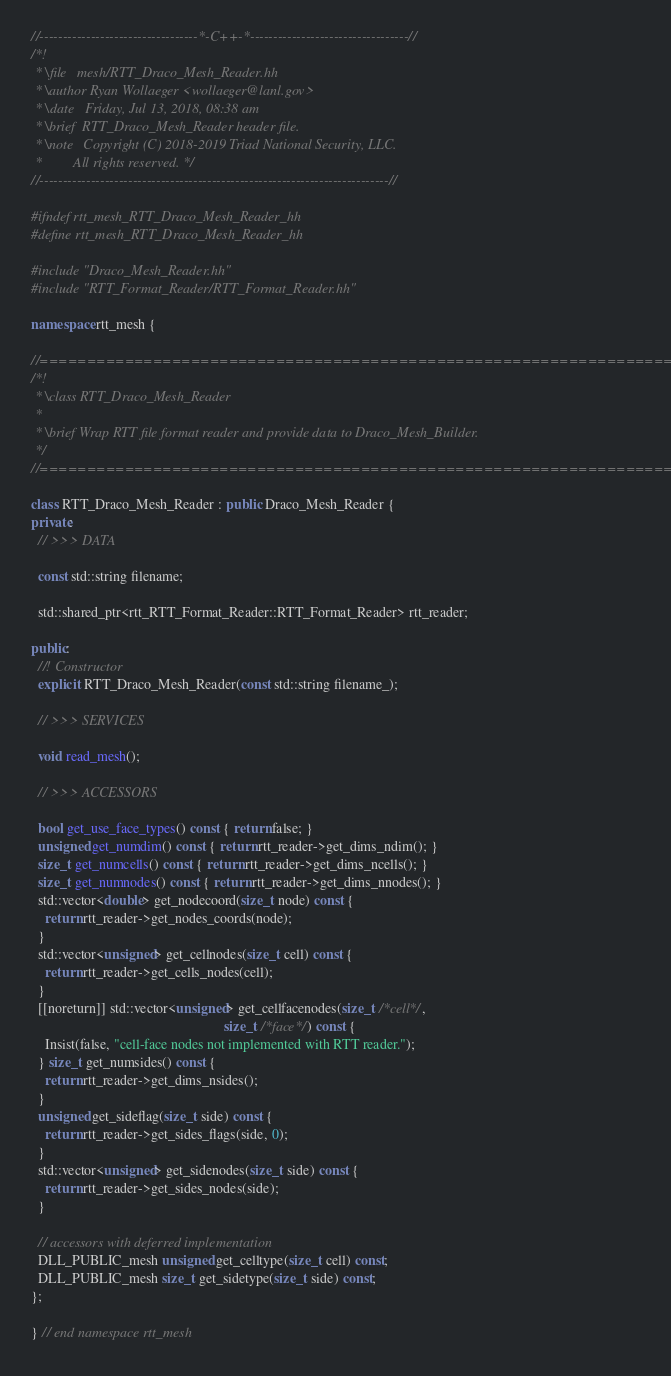Convert code to text. <code><loc_0><loc_0><loc_500><loc_500><_C++_>//----------------------------------*-C++-*----------------------------------//
/*!
 * \file   mesh/RTT_Draco_Mesh_Reader.hh
 * \author Ryan Wollaeger <wollaeger@lanl.gov>
 * \date   Friday, Jul 13, 2018, 08:38 am
 * \brief  RTT_Draco_Mesh_Reader header file.
 * \note   Copyright (C) 2018-2019 Triad National Security, LLC.
 *         All rights reserved. */
//---------------------------------------------------------------------------//

#ifndef rtt_mesh_RTT_Draco_Mesh_Reader_hh
#define rtt_mesh_RTT_Draco_Mesh_Reader_hh

#include "Draco_Mesh_Reader.hh"
#include "RTT_Format_Reader/RTT_Format_Reader.hh"

namespace rtt_mesh {

//===========================================================================//
/*!
 * \class RTT_Draco_Mesh_Reader
 *
 * \brief Wrap RTT file format reader and provide data to Draco_Mesh_Builder.
 */
//===========================================================================//

class RTT_Draco_Mesh_Reader : public Draco_Mesh_Reader {
private:
  // >>> DATA

  const std::string filename;

  std::shared_ptr<rtt_RTT_Format_Reader::RTT_Format_Reader> rtt_reader;

public:
  //! Constructor
  explicit RTT_Draco_Mesh_Reader(const std::string filename_);

  // >>> SERVICES

  void read_mesh();

  // >>> ACCESSORS

  bool get_use_face_types() const { return false; }
  unsigned get_numdim() const { return rtt_reader->get_dims_ndim(); }
  size_t get_numcells() const { return rtt_reader->get_dims_ncells(); }
  size_t get_numnodes() const { return rtt_reader->get_dims_nnodes(); }
  std::vector<double> get_nodecoord(size_t node) const {
    return rtt_reader->get_nodes_coords(node);
  }
  std::vector<unsigned> get_cellnodes(size_t cell) const {
    return rtt_reader->get_cells_nodes(cell);
  }
  [[noreturn]] std::vector<unsigned> get_cellfacenodes(size_t /*cell*/,
                                                       size_t /*face*/) const {
    Insist(false, "cell-face nodes not implemented with RTT reader.");
  } size_t get_numsides() const {
    return rtt_reader->get_dims_nsides();
  }
  unsigned get_sideflag(size_t side) const {
    return rtt_reader->get_sides_flags(side, 0);
  }
  std::vector<unsigned> get_sidenodes(size_t side) const {
    return rtt_reader->get_sides_nodes(side);
  }

  // accessors with deferred implementation
  DLL_PUBLIC_mesh unsigned get_celltype(size_t cell) const;
  DLL_PUBLIC_mesh size_t get_sidetype(size_t side) const;
};

} // end namespace rtt_mesh
</code> 